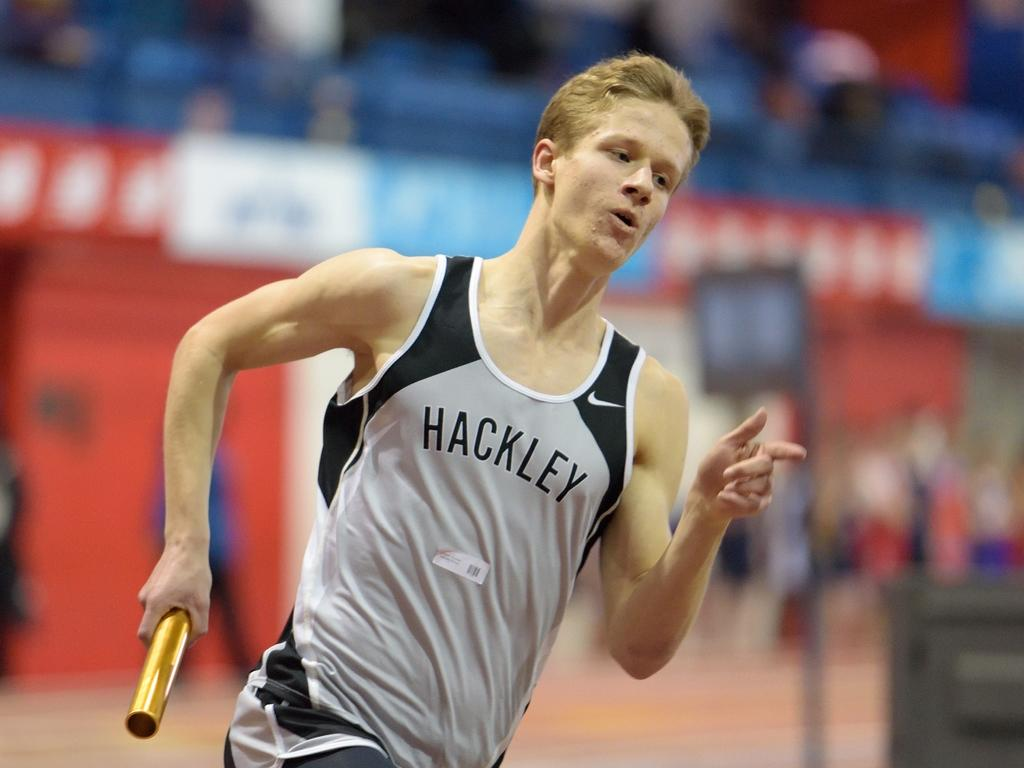Provide a one-sentence caption for the provided image. Man wearing Hackley jersey running a race while holding a baton. 